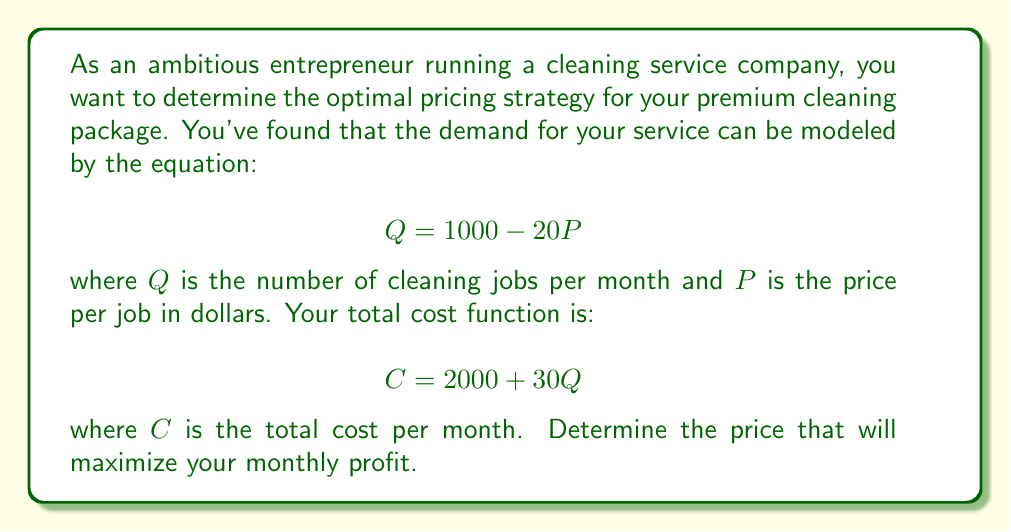Help me with this question. To solve this problem, we'll follow these steps:

1) First, let's define the profit function. Profit is revenue minus cost:

   $$ \text{Profit} = \text{Revenue} - \text{Cost} $$

2) Revenue is price times quantity: $R = PQ$

3) We can express Q in terms of P using the demand equation:
   $$ Q = 1000 - 20P $$

4) Now, let's write out the profit function:
   $$ \text{Profit} = P(1000 - 20P) - (2000 + 30(1000 - 20P)) $$

5) Simplify:
   $$ \text{Profit} = 1000P - 20P^2 - 2000 - 30000 + 600P $$
   $$ \text{Profit} = -20P^2 + 1600P - 32000 $$

6) To find the maximum profit, we need to find the vertex of this quadratic function. The vertex occurs at the average of the roots, or at $-b/(2a)$ where $a$ and $b$ are the coefficients of the quadratic in standard form $(ax^2 + bx + c)$.

7) In this case, $a = -20$ and $b = 1600$. So the optimal price is:
   $$ P = -\frac{1600}{2(-20)} = \frac{1600}{40} = 40 $$

8) To verify this is a maximum (not a minimum), we can check that $a$ is negative, which it is $(-20)$.
Answer: The optimal price to maximize monthly profit is $40 per cleaning job. 